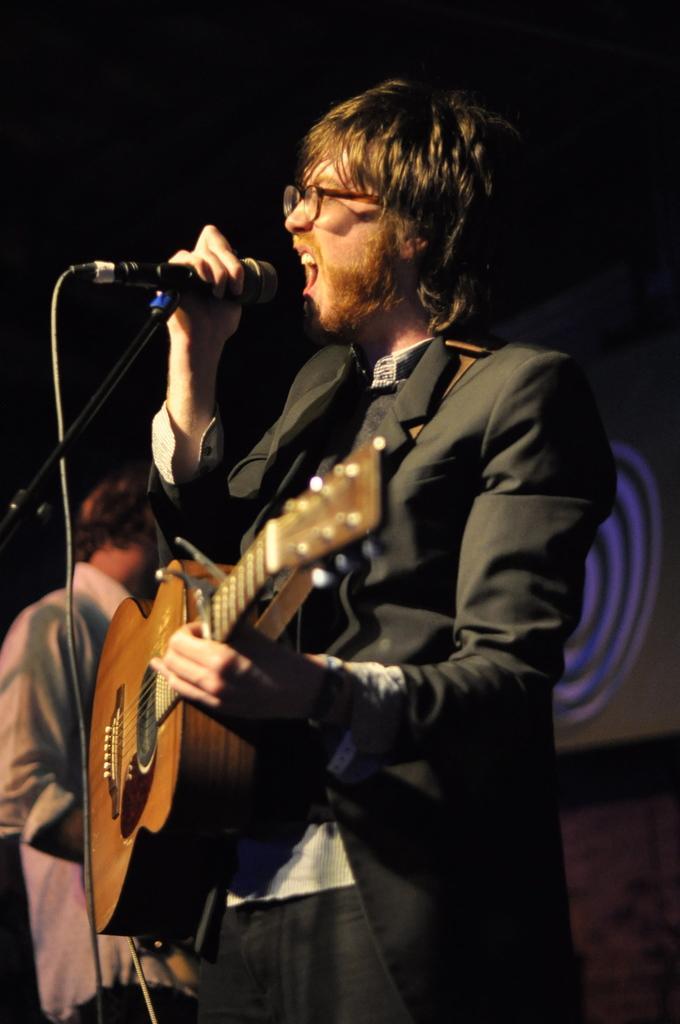In one or two sentences, can you explain what this image depicts? A man is singing with a mic in front of him and playing guitar. 